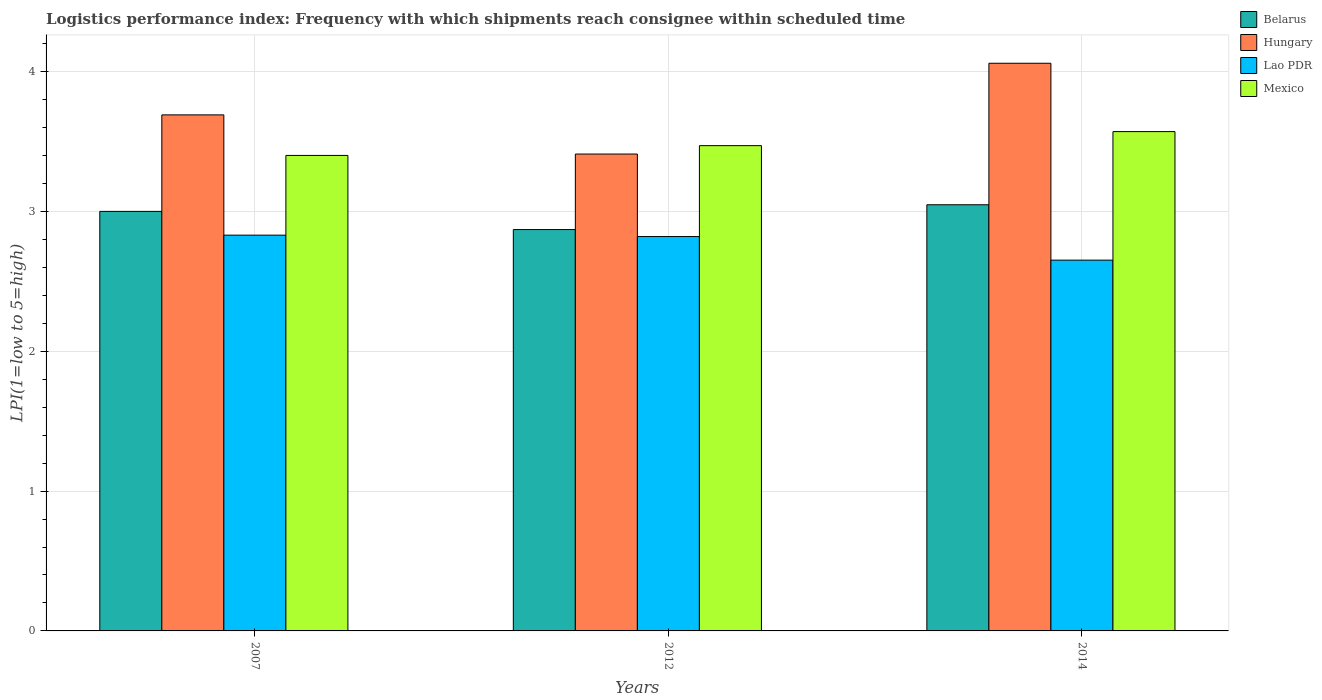Are the number of bars per tick equal to the number of legend labels?
Offer a terse response. Yes. In how many cases, is the number of bars for a given year not equal to the number of legend labels?
Your response must be concise. 0. Across all years, what is the maximum logistics performance index in Belarus?
Your response must be concise. 3.05. Across all years, what is the minimum logistics performance index in Lao PDR?
Keep it short and to the point. 2.65. What is the total logistics performance index in Belarus in the graph?
Your answer should be very brief. 8.92. What is the difference between the logistics performance index in Belarus in 2007 and that in 2012?
Give a very brief answer. 0.13. What is the difference between the logistics performance index in Lao PDR in 2007 and the logistics performance index in Hungary in 2014?
Your answer should be compact. -1.23. What is the average logistics performance index in Mexico per year?
Offer a terse response. 3.48. In the year 2014, what is the difference between the logistics performance index in Mexico and logistics performance index in Lao PDR?
Keep it short and to the point. 0.92. What is the ratio of the logistics performance index in Hungary in 2007 to that in 2014?
Ensure brevity in your answer.  0.91. Is the logistics performance index in Belarus in 2012 less than that in 2014?
Your response must be concise. Yes. What is the difference between the highest and the second highest logistics performance index in Belarus?
Keep it short and to the point. 0.05. What is the difference between the highest and the lowest logistics performance index in Lao PDR?
Give a very brief answer. 0.18. Is the sum of the logistics performance index in Belarus in 2007 and 2014 greater than the maximum logistics performance index in Hungary across all years?
Your response must be concise. Yes. What does the 3rd bar from the left in 2012 represents?
Offer a very short reply. Lao PDR. What does the 3rd bar from the right in 2007 represents?
Offer a very short reply. Hungary. Is it the case that in every year, the sum of the logistics performance index in Belarus and logistics performance index in Mexico is greater than the logistics performance index in Lao PDR?
Provide a short and direct response. Yes. Are all the bars in the graph horizontal?
Offer a terse response. No. Does the graph contain any zero values?
Keep it short and to the point. No. What is the title of the graph?
Make the answer very short. Logistics performance index: Frequency with which shipments reach consignee within scheduled time. What is the label or title of the X-axis?
Offer a terse response. Years. What is the label or title of the Y-axis?
Give a very brief answer. LPI(1=low to 5=high). What is the LPI(1=low to 5=high) of Belarus in 2007?
Ensure brevity in your answer.  3. What is the LPI(1=low to 5=high) of Hungary in 2007?
Offer a terse response. 3.69. What is the LPI(1=low to 5=high) in Lao PDR in 2007?
Your answer should be compact. 2.83. What is the LPI(1=low to 5=high) in Mexico in 2007?
Your response must be concise. 3.4. What is the LPI(1=low to 5=high) in Belarus in 2012?
Provide a succinct answer. 2.87. What is the LPI(1=low to 5=high) of Hungary in 2012?
Make the answer very short. 3.41. What is the LPI(1=low to 5=high) of Lao PDR in 2012?
Provide a succinct answer. 2.82. What is the LPI(1=low to 5=high) of Mexico in 2012?
Your answer should be compact. 3.47. What is the LPI(1=low to 5=high) of Belarus in 2014?
Offer a very short reply. 3.05. What is the LPI(1=low to 5=high) of Hungary in 2014?
Provide a succinct answer. 4.06. What is the LPI(1=low to 5=high) of Lao PDR in 2014?
Offer a terse response. 2.65. What is the LPI(1=low to 5=high) of Mexico in 2014?
Give a very brief answer. 3.57. Across all years, what is the maximum LPI(1=low to 5=high) in Belarus?
Your response must be concise. 3.05. Across all years, what is the maximum LPI(1=low to 5=high) of Hungary?
Give a very brief answer. 4.06. Across all years, what is the maximum LPI(1=low to 5=high) in Lao PDR?
Offer a very short reply. 2.83. Across all years, what is the maximum LPI(1=low to 5=high) of Mexico?
Provide a succinct answer. 3.57. Across all years, what is the minimum LPI(1=low to 5=high) in Belarus?
Keep it short and to the point. 2.87. Across all years, what is the minimum LPI(1=low to 5=high) of Hungary?
Your answer should be very brief. 3.41. Across all years, what is the minimum LPI(1=low to 5=high) of Lao PDR?
Your response must be concise. 2.65. Across all years, what is the minimum LPI(1=low to 5=high) of Mexico?
Give a very brief answer. 3.4. What is the total LPI(1=low to 5=high) in Belarus in the graph?
Your answer should be very brief. 8.92. What is the total LPI(1=low to 5=high) in Hungary in the graph?
Offer a very short reply. 11.16. What is the total LPI(1=low to 5=high) in Lao PDR in the graph?
Provide a short and direct response. 8.3. What is the total LPI(1=low to 5=high) of Mexico in the graph?
Your answer should be very brief. 10.44. What is the difference between the LPI(1=low to 5=high) of Belarus in 2007 and that in 2012?
Your response must be concise. 0.13. What is the difference between the LPI(1=low to 5=high) of Hungary in 2007 and that in 2012?
Give a very brief answer. 0.28. What is the difference between the LPI(1=low to 5=high) of Lao PDR in 2007 and that in 2012?
Make the answer very short. 0.01. What is the difference between the LPI(1=low to 5=high) of Mexico in 2007 and that in 2012?
Make the answer very short. -0.07. What is the difference between the LPI(1=low to 5=high) in Belarus in 2007 and that in 2014?
Offer a very short reply. -0.05. What is the difference between the LPI(1=low to 5=high) of Hungary in 2007 and that in 2014?
Your response must be concise. -0.37. What is the difference between the LPI(1=low to 5=high) in Lao PDR in 2007 and that in 2014?
Ensure brevity in your answer.  0.18. What is the difference between the LPI(1=low to 5=high) in Mexico in 2007 and that in 2014?
Your answer should be very brief. -0.17. What is the difference between the LPI(1=low to 5=high) in Belarus in 2012 and that in 2014?
Provide a short and direct response. -0.18. What is the difference between the LPI(1=low to 5=high) in Hungary in 2012 and that in 2014?
Your response must be concise. -0.65. What is the difference between the LPI(1=low to 5=high) in Lao PDR in 2012 and that in 2014?
Make the answer very short. 0.17. What is the difference between the LPI(1=low to 5=high) in Mexico in 2012 and that in 2014?
Offer a terse response. -0.1. What is the difference between the LPI(1=low to 5=high) in Belarus in 2007 and the LPI(1=low to 5=high) in Hungary in 2012?
Your answer should be compact. -0.41. What is the difference between the LPI(1=low to 5=high) in Belarus in 2007 and the LPI(1=low to 5=high) in Lao PDR in 2012?
Keep it short and to the point. 0.18. What is the difference between the LPI(1=low to 5=high) of Belarus in 2007 and the LPI(1=low to 5=high) of Mexico in 2012?
Make the answer very short. -0.47. What is the difference between the LPI(1=low to 5=high) in Hungary in 2007 and the LPI(1=low to 5=high) in Lao PDR in 2012?
Make the answer very short. 0.87. What is the difference between the LPI(1=low to 5=high) of Hungary in 2007 and the LPI(1=low to 5=high) of Mexico in 2012?
Your response must be concise. 0.22. What is the difference between the LPI(1=low to 5=high) of Lao PDR in 2007 and the LPI(1=low to 5=high) of Mexico in 2012?
Offer a terse response. -0.64. What is the difference between the LPI(1=low to 5=high) of Belarus in 2007 and the LPI(1=low to 5=high) of Hungary in 2014?
Your answer should be compact. -1.06. What is the difference between the LPI(1=low to 5=high) of Belarus in 2007 and the LPI(1=low to 5=high) of Lao PDR in 2014?
Your answer should be compact. 0.35. What is the difference between the LPI(1=low to 5=high) of Belarus in 2007 and the LPI(1=low to 5=high) of Mexico in 2014?
Your answer should be very brief. -0.57. What is the difference between the LPI(1=low to 5=high) in Hungary in 2007 and the LPI(1=low to 5=high) in Lao PDR in 2014?
Ensure brevity in your answer.  1.04. What is the difference between the LPI(1=low to 5=high) of Hungary in 2007 and the LPI(1=low to 5=high) of Mexico in 2014?
Give a very brief answer. 0.12. What is the difference between the LPI(1=low to 5=high) in Lao PDR in 2007 and the LPI(1=low to 5=high) in Mexico in 2014?
Make the answer very short. -0.74. What is the difference between the LPI(1=low to 5=high) of Belarus in 2012 and the LPI(1=low to 5=high) of Hungary in 2014?
Provide a succinct answer. -1.19. What is the difference between the LPI(1=low to 5=high) in Belarus in 2012 and the LPI(1=low to 5=high) in Lao PDR in 2014?
Your answer should be compact. 0.22. What is the difference between the LPI(1=low to 5=high) of Belarus in 2012 and the LPI(1=low to 5=high) of Mexico in 2014?
Ensure brevity in your answer.  -0.7. What is the difference between the LPI(1=low to 5=high) of Hungary in 2012 and the LPI(1=low to 5=high) of Lao PDR in 2014?
Provide a short and direct response. 0.76. What is the difference between the LPI(1=low to 5=high) in Hungary in 2012 and the LPI(1=low to 5=high) in Mexico in 2014?
Keep it short and to the point. -0.16. What is the difference between the LPI(1=low to 5=high) of Lao PDR in 2012 and the LPI(1=low to 5=high) of Mexico in 2014?
Give a very brief answer. -0.75. What is the average LPI(1=low to 5=high) of Belarus per year?
Make the answer very short. 2.97. What is the average LPI(1=low to 5=high) in Hungary per year?
Keep it short and to the point. 3.72. What is the average LPI(1=low to 5=high) in Lao PDR per year?
Provide a succinct answer. 2.77. What is the average LPI(1=low to 5=high) in Mexico per year?
Offer a very short reply. 3.48. In the year 2007, what is the difference between the LPI(1=low to 5=high) of Belarus and LPI(1=low to 5=high) of Hungary?
Make the answer very short. -0.69. In the year 2007, what is the difference between the LPI(1=low to 5=high) of Belarus and LPI(1=low to 5=high) of Lao PDR?
Provide a short and direct response. 0.17. In the year 2007, what is the difference between the LPI(1=low to 5=high) in Belarus and LPI(1=low to 5=high) in Mexico?
Make the answer very short. -0.4. In the year 2007, what is the difference between the LPI(1=low to 5=high) of Hungary and LPI(1=low to 5=high) of Lao PDR?
Make the answer very short. 0.86. In the year 2007, what is the difference between the LPI(1=low to 5=high) in Hungary and LPI(1=low to 5=high) in Mexico?
Ensure brevity in your answer.  0.29. In the year 2007, what is the difference between the LPI(1=low to 5=high) in Lao PDR and LPI(1=low to 5=high) in Mexico?
Provide a succinct answer. -0.57. In the year 2012, what is the difference between the LPI(1=low to 5=high) in Belarus and LPI(1=low to 5=high) in Hungary?
Offer a very short reply. -0.54. In the year 2012, what is the difference between the LPI(1=low to 5=high) of Belarus and LPI(1=low to 5=high) of Lao PDR?
Make the answer very short. 0.05. In the year 2012, what is the difference between the LPI(1=low to 5=high) of Hungary and LPI(1=low to 5=high) of Lao PDR?
Provide a succinct answer. 0.59. In the year 2012, what is the difference between the LPI(1=low to 5=high) in Hungary and LPI(1=low to 5=high) in Mexico?
Ensure brevity in your answer.  -0.06. In the year 2012, what is the difference between the LPI(1=low to 5=high) in Lao PDR and LPI(1=low to 5=high) in Mexico?
Give a very brief answer. -0.65. In the year 2014, what is the difference between the LPI(1=low to 5=high) in Belarus and LPI(1=low to 5=high) in Hungary?
Keep it short and to the point. -1.01. In the year 2014, what is the difference between the LPI(1=low to 5=high) of Belarus and LPI(1=low to 5=high) of Lao PDR?
Ensure brevity in your answer.  0.4. In the year 2014, what is the difference between the LPI(1=low to 5=high) in Belarus and LPI(1=low to 5=high) in Mexico?
Make the answer very short. -0.52. In the year 2014, what is the difference between the LPI(1=low to 5=high) of Hungary and LPI(1=low to 5=high) of Lao PDR?
Provide a short and direct response. 1.41. In the year 2014, what is the difference between the LPI(1=low to 5=high) in Hungary and LPI(1=low to 5=high) in Mexico?
Your answer should be compact. 0.49. In the year 2014, what is the difference between the LPI(1=low to 5=high) of Lao PDR and LPI(1=low to 5=high) of Mexico?
Your answer should be compact. -0.92. What is the ratio of the LPI(1=low to 5=high) in Belarus in 2007 to that in 2012?
Provide a short and direct response. 1.05. What is the ratio of the LPI(1=low to 5=high) of Hungary in 2007 to that in 2012?
Give a very brief answer. 1.08. What is the ratio of the LPI(1=low to 5=high) in Lao PDR in 2007 to that in 2012?
Provide a short and direct response. 1. What is the ratio of the LPI(1=low to 5=high) in Mexico in 2007 to that in 2012?
Give a very brief answer. 0.98. What is the ratio of the LPI(1=low to 5=high) in Belarus in 2007 to that in 2014?
Give a very brief answer. 0.98. What is the ratio of the LPI(1=low to 5=high) in Hungary in 2007 to that in 2014?
Provide a succinct answer. 0.91. What is the ratio of the LPI(1=low to 5=high) of Lao PDR in 2007 to that in 2014?
Offer a very short reply. 1.07. What is the ratio of the LPI(1=low to 5=high) in Mexico in 2007 to that in 2014?
Make the answer very short. 0.95. What is the ratio of the LPI(1=low to 5=high) of Belarus in 2012 to that in 2014?
Ensure brevity in your answer.  0.94. What is the ratio of the LPI(1=low to 5=high) of Hungary in 2012 to that in 2014?
Keep it short and to the point. 0.84. What is the ratio of the LPI(1=low to 5=high) in Lao PDR in 2012 to that in 2014?
Your answer should be very brief. 1.06. What is the ratio of the LPI(1=low to 5=high) of Mexico in 2012 to that in 2014?
Provide a succinct answer. 0.97. What is the difference between the highest and the second highest LPI(1=low to 5=high) in Belarus?
Make the answer very short. 0.05. What is the difference between the highest and the second highest LPI(1=low to 5=high) of Hungary?
Provide a short and direct response. 0.37. What is the difference between the highest and the second highest LPI(1=low to 5=high) of Lao PDR?
Your response must be concise. 0.01. What is the difference between the highest and the second highest LPI(1=low to 5=high) in Mexico?
Your answer should be compact. 0.1. What is the difference between the highest and the lowest LPI(1=low to 5=high) in Belarus?
Provide a succinct answer. 0.18. What is the difference between the highest and the lowest LPI(1=low to 5=high) in Hungary?
Make the answer very short. 0.65. What is the difference between the highest and the lowest LPI(1=low to 5=high) of Lao PDR?
Ensure brevity in your answer.  0.18. What is the difference between the highest and the lowest LPI(1=low to 5=high) of Mexico?
Offer a very short reply. 0.17. 